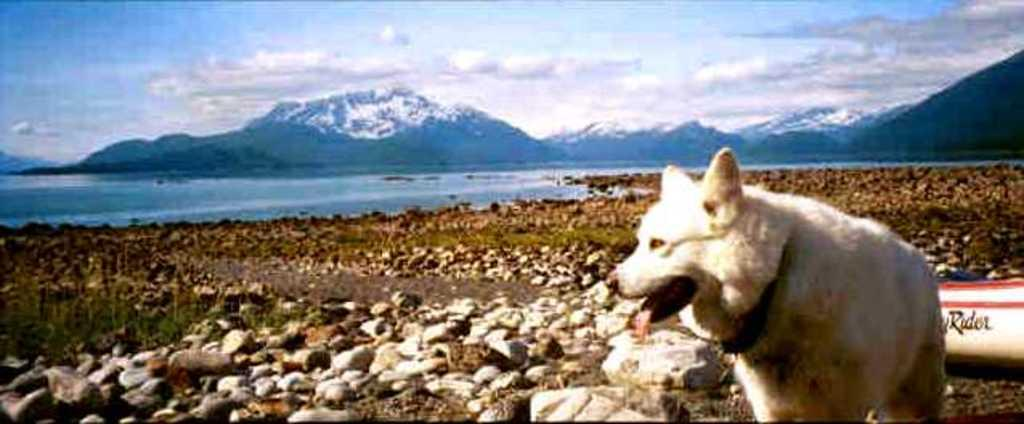What is the main subject in the front of the image? There is an animal in the front of the image. What can be seen on the ground in the center of the image? There are stones on the ground in the center of the image. What is visible in the background of the image? There are mountains in the background of the image. How would you describe the sky in the image? The sky is cloudy in the image. How many nuts are being carried by the ants in the image? There are no ants or nuts present in the image. What decision is the animal making in the image? The image does not depict the animal making any decisions; it simply shows the animal in the foreground. 